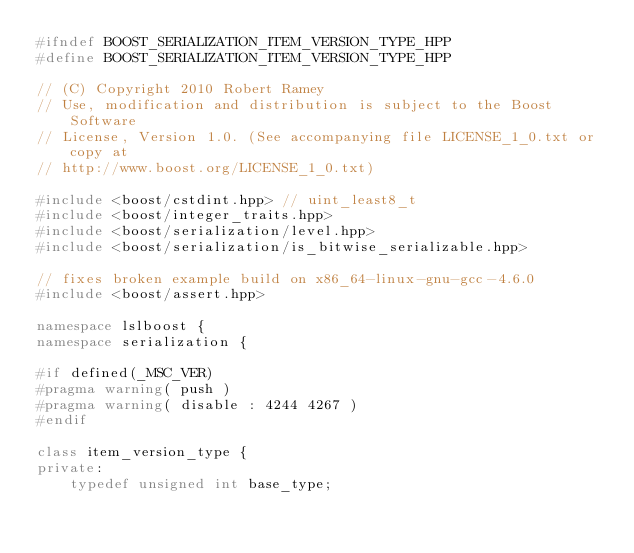Convert code to text. <code><loc_0><loc_0><loc_500><loc_500><_C++_>#ifndef BOOST_SERIALIZATION_ITEM_VERSION_TYPE_HPP
#define BOOST_SERIALIZATION_ITEM_VERSION_TYPE_HPP

// (C) Copyright 2010 Robert Ramey
// Use, modification and distribution is subject to the Boost Software
// License, Version 1.0. (See accompanying file LICENSE_1_0.txt or copy at
// http://www.boost.org/LICENSE_1_0.txt)

#include <boost/cstdint.hpp> // uint_least8_t
#include <boost/integer_traits.hpp>
#include <boost/serialization/level.hpp>
#include <boost/serialization/is_bitwise_serializable.hpp>

// fixes broken example build on x86_64-linux-gnu-gcc-4.6.0
#include <boost/assert.hpp>

namespace lslboost {
namespace serialization {

#if defined(_MSC_VER)
#pragma warning( push )
#pragma warning( disable : 4244 4267 )
#endif

class item_version_type {
private:
    typedef unsigned int base_type;</code> 